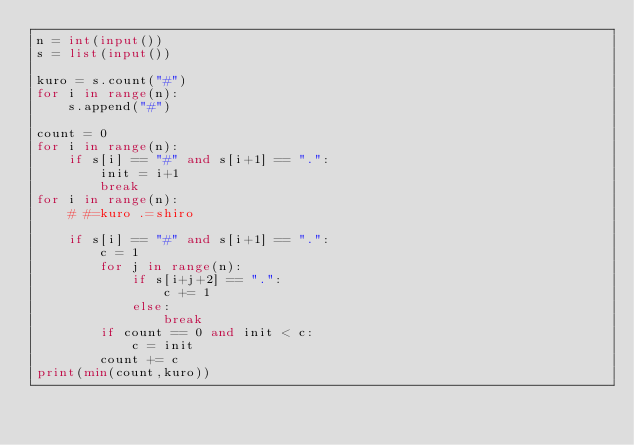Convert code to text. <code><loc_0><loc_0><loc_500><loc_500><_Python_>n = int(input())
s = list(input())

kuro = s.count("#")
for i in range(n):
    s.append("#")

count = 0
for i in range(n):
    if s[i] == "#" and s[i+1] == ".":
        init = i+1
        break
for i in range(n):
    # #=kuro .=shiro

    if s[i] == "#" and s[i+1] == ".":
        c = 1
        for j in range(n):
            if s[i+j+2] == ".":
                c += 1
            else:
                break
        if count == 0 and init < c:
            c = init
        count += c
print(min(count,kuro))
</code> 